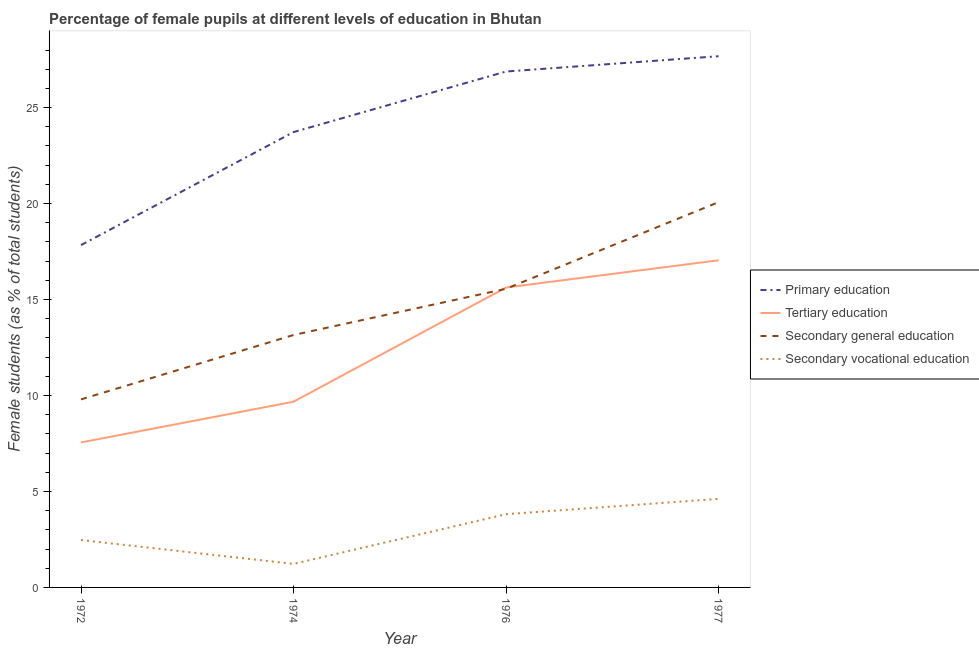How many different coloured lines are there?
Keep it short and to the point. 4. What is the percentage of female students in secondary vocational education in 1972?
Keep it short and to the point. 2.47. Across all years, what is the maximum percentage of female students in secondary vocational education?
Offer a very short reply. 4.61. Across all years, what is the minimum percentage of female students in tertiary education?
Provide a succinct answer. 7.55. In which year was the percentage of female students in secondary vocational education maximum?
Offer a terse response. 1977. In which year was the percentage of female students in secondary education minimum?
Offer a very short reply. 1972. What is the total percentage of female students in secondary vocational education in the graph?
Your answer should be very brief. 12.12. What is the difference between the percentage of female students in primary education in 1974 and that in 1977?
Make the answer very short. -3.95. What is the difference between the percentage of female students in secondary education in 1977 and the percentage of female students in tertiary education in 1976?
Provide a succinct answer. 4.45. What is the average percentage of female students in primary education per year?
Give a very brief answer. 24.03. In the year 1972, what is the difference between the percentage of female students in secondary vocational education and percentage of female students in secondary education?
Your answer should be very brief. -7.33. In how many years, is the percentage of female students in secondary vocational education greater than 4 %?
Your response must be concise. 1. What is the ratio of the percentage of female students in primary education in 1972 to that in 1974?
Offer a very short reply. 0.75. Is the percentage of female students in secondary vocational education in 1972 less than that in 1977?
Your answer should be compact. Yes. Is the difference between the percentage of female students in tertiary education in 1974 and 1977 greater than the difference between the percentage of female students in secondary education in 1974 and 1977?
Your answer should be compact. No. What is the difference between the highest and the second highest percentage of female students in primary education?
Offer a very short reply. 0.8. What is the difference between the highest and the lowest percentage of female students in secondary education?
Provide a short and direct response. 10.28. In how many years, is the percentage of female students in secondary vocational education greater than the average percentage of female students in secondary vocational education taken over all years?
Give a very brief answer. 2. Is it the case that in every year, the sum of the percentage of female students in secondary education and percentage of female students in tertiary education is greater than the sum of percentage of female students in secondary vocational education and percentage of female students in primary education?
Your answer should be compact. No. Is it the case that in every year, the sum of the percentage of female students in primary education and percentage of female students in tertiary education is greater than the percentage of female students in secondary education?
Your answer should be compact. Yes. Is the percentage of female students in secondary education strictly greater than the percentage of female students in tertiary education over the years?
Give a very brief answer. No. Is the percentage of female students in secondary education strictly less than the percentage of female students in secondary vocational education over the years?
Your answer should be very brief. No. How many lines are there?
Offer a terse response. 4. Does the graph contain grids?
Offer a very short reply. No. Where does the legend appear in the graph?
Provide a short and direct response. Center right. How many legend labels are there?
Offer a very short reply. 4. What is the title of the graph?
Keep it short and to the point. Percentage of female pupils at different levels of education in Bhutan. Does "Korea" appear as one of the legend labels in the graph?
Offer a very short reply. No. What is the label or title of the X-axis?
Ensure brevity in your answer.  Year. What is the label or title of the Y-axis?
Offer a very short reply. Female students (as % of total students). What is the Female students (as % of total students) in Primary education in 1972?
Provide a short and direct response. 17.84. What is the Female students (as % of total students) of Tertiary education in 1972?
Offer a very short reply. 7.55. What is the Female students (as % of total students) of Secondary general education in 1972?
Your answer should be compact. 9.8. What is the Female students (as % of total students) of Secondary vocational education in 1972?
Offer a terse response. 2.47. What is the Female students (as % of total students) in Primary education in 1974?
Provide a succinct answer. 23.72. What is the Female students (as % of total students) in Tertiary education in 1974?
Your answer should be compact. 9.68. What is the Female students (as % of total students) of Secondary general education in 1974?
Your answer should be very brief. 13.15. What is the Female students (as % of total students) of Secondary vocational education in 1974?
Your answer should be compact. 1.23. What is the Female students (as % of total students) in Primary education in 1976?
Give a very brief answer. 26.88. What is the Female students (as % of total students) of Tertiary education in 1976?
Provide a succinct answer. 15.62. What is the Female students (as % of total students) in Secondary general education in 1976?
Provide a succinct answer. 15.56. What is the Female students (as % of total students) in Secondary vocational education in 1976?
Offer a very short reply. 3.81. What is the Female students (as % of total students) in Primary education in 1977?
Ensure brevity in your answer.  27.68. What is the Female students (as % of total students) of Tertiary education in 1977?
Give a very brief answer. 17.04. What is the Female students (as % of total students) of Secondary general education in 1977?
Keep it short and to the point. 20.07. What is the Female students (as % of total students) of Secondary vocational education in 1977?
Your response must be concise. 4.61. Across all years, what is the maximum Female students (as % of total students) of Primary education?
Provide a succinct answer. 27.68. Across all years, what is the maximum Female students (as % of total students) in Tertiary education?
Provide a short and direct response. 17.04. Across all years, what is the maximum Female students (as % of total students) of Secondary general education?
Your answer should be very brief. 20.07. Across all years, what is the maximum Female students (as % of total students) in Secondary vocational education?
Your answer should be compact. 4.61. Across all years, what is the minimum Female students (as % of total students) of Primary education?
Your answer should be very brief. 17.84. Across all years, what is the minimum Female students (as % of total students) in Tertiary education?
Your response must be concise. 7.55. Across all years, what is the minimum Female students (as % of total students) in Secondary general education?
Ensure brevity in your answer.  9.8. Across all years, what is the minimum Female students (as % of total students) in Secondary vocational education?
Your answer should be compact. 1.23. What is the total Female students (as % of total students) in Primary education in the graph?
Your answer should be compact. 96.12. What is the total Female students (as % of total students) of Tertiary education in the graph?
Keep it short and to the point. 49.9. What is the total Female students (as % of total students) in Secondary general education in the graph?
Give a very brief answer. 58.58. What is the total Female students (as % of total students) in Secondary vocational education in the graph?
Your response must be concise. 12.12. What is the difference between the Female students (as % of total students) of Primary education in 1972 and that in 1974?
Provide a short and direct response. -5.89. What is the difference between the Female students (as % of total students) of Tertiary education in 1972 and that in 1974?
Ensure brevity in your answer.  -2.12. What is the difference between the Female students (as % of total students) in Secondary general education in 1972 and that in 1974?
Your response must be concise. -3.36. What is the difference between the Female students (as % of total students) of Secondary vocational education in 1972 and that in 1974?
Provide a short and direct response. 1.24. What is the difference between the Female students (as % of total students) of Primary education in 1972 and that in 1976?
Provide a short and direct response. -9.04. What is the difference between the Female students (as % of total students) in Tertiary education in 1972 and that in 1976?
Your response must be concise. -8.07. What is the difference between the Female students (as % of total students) in Secondary general education in 1972 and that in 1976?
Offer a terse response. -5.76. What is the difference between the Female students (as % of total students) of Secondary vocational education in 1972 and that in 1976?
Your answer should be very brief. -1.35. What is the difference between the Female students (as % of total students) of Primary education in 1972 and that in 1977?
Make the answer very short. -9.84. What is the difference between the Female students (as % of total students) of Tertiary education in 1972 and that in 1977?
Provide a succinct answer. -9.49. What is the difference between the Female students (as % of total students) of Secondary general education in 1972 and that in 1977?
Ensure brevity in your answer.  -10.28. What is the difference between the Female students (as % of total students) of Secondary vocational education in 1972 and that in 1977?
Provide a succinct answer. -2.14. What is the difference between the Female students (as % of total students) in Primary education in 1974 and that in 1976?
Keep it short and to the point. -3.16. What is the difference between the Female students (as % of total students) in Tertiary education in 1974 and that in 1976?
Keep it short and to the point. -5.95. What is the difference between the Female students (as % of total students) in Secondary general education in 1974 and that in 1976?
Make the answer very short. -2.41. What is the difference between the Female students (as % of total students) of Secondary vocational education in 1974 and that in 1976?
Ensure brevity in your answer.  -2.59. What is the difference between the Female students (as % of total students) in Primary education in 1974 and that in 1977?
Give a very brief answer. -3.95. What is the difference between the Female students (as % of total students) of Tertiary education in 1974 and that in 1977?
Provide a short and direct response. -7.37. What is the difference between the Female students (as % of total students) in Secondary general education in 1974 and that in 1977?
Give a very brief answer. -6.92. What is the difference between the Female students (as % of total students) of Secondary vocational education in 1974 and that in 1977?
Your response must be concise. -3.39. What is the difference between the Female students (as % of total students) in Primary education in 1976 and that in 1977?
Provide a short and direct response. -0.8. What is the difference between the Female students (as % of total students) in Tertiary education in 1976 and that in 1977?
Make the answer very short. -1.42. What is the difference between the Female students (as % of total students) in Secondary general education in 1976 and that in 1977?
Provide a short and direct response. -4.51. What is the difference between the Female students (as % of total students) in Secondary vocational education in 1976 and that in 1977?
Ensure brevity in your answer.  -0.8. What is the difference between the Female students (as % of total students) in Primary education in 1972 and the Female students (as % of total students) in Tertiary education in 1974?
Make the answer very short. 8.16. What is the difference between the Female students (as % of total students) in Primary education in 1972 and the Female students (as % of total students) in Secondary general education in 1974?
Ensure brevity in your answer.  4.68. What is the difference between the Female students (as % of total students) in Primary education in 1972 and the Female students (as % of total students) in Secondary vocational education in 1974?
Keep it short and to the point. 16.61. What is the difference between the Female students (as % of total students) of Tertiary education in 1972 and the Female students (as % of total students) of Secondary general education in 1974?
Offer a very short reply. -5.6. What is the difference between the Female students (as % of total students) of Tertiary education in 1972 and the Female students (as % of total students) of Secondary vocational education in 1974?
Offer a very short reply. 6.33. What is the difference between the Female students (as % of total students) of Secondary general education in 1972 and the Female students (as % of total students) of Secondary vocational education in 1974?
Provide a short and direct response. 8.57. What is the difference between the Female students (as % of total students) of Primary education in 1972 and the Female students (as % of total students) of Tertiary education in 1976?
Provide a short and direct response. 2.21. What is the difference between the Female students (as % of total students) in Primary education in 1972 and the Female students (as % of total students) in Secondary general education in 1976?
Your answer should be compact. 2.28. What is the difference between the Female students (as % of total students) of Primary education in 1972 and the Female students (as % of total students) of Secondary vocational education in 1976?
Provide a succinct answer. 14.02. What is the difference between the Female students (as % of total students) of Tertiary education in 1972 and the Female students (as % of total students) of Secondary general education in 1976?
Keep it short and to the point. -8.01. What is the difference between the Female students (as % of total students) of Tertiary education in 1972 and the Female students (as % of total students) of Secondary vocational education in 1976?
Provide a succinct answer. 3.74. What is the difference between the Female students (as % of total students) of Secondary general education in 1972 and the Female students (as % of total students) of Secondary vocational education in 1976?
Make the answer very short. 5.98. What is the difference between the Female students (as % of total students) of Primary education in 1972 and the Female students (as % of total students) of Tertiary education in 1977?
Make the answer very short. 0.79. What is the difference between the Female students (as % of total students) of Primary education in 1972 and the Female students (as % of total students) of Secondary general education in 1977?
Your answer should be compact. -2.24. What is the difference between the Female students (as % of total students) in Primary education in 1972 and the Female students (as % of total students) in Secondary vocational education in 1977?
Offer a very short reply. 13.22. What is the difference between the Female students (as % of total students) in Tertiary education in 1972 and the Female students (as % of total students) in Secondary general education in 1977?
Ensure brevity in your answer.  -12.52. What is the difference between the Female students (as % of total students) of Tertiary education in 1972 and the Female students (as % of total students) of Secondary vocational education in 1977?
Offer a terse response. 2.94. What is the difference between the Female students (as % of total students) in Secondary general education in 1972 and the Female students (as % of total students) in Secondary vocational education in 1977?
Provide a succinct answer. 5.18. What is the difference between the Female students (as % of total students) in Primary education in 1974 and the Female students (as % of total students) in Tertiary education in 1976?
Give a very brief answer. 8.1. What is the difference between the Female students (as % of total students) in Primary education in 1974 and the Female students (as % of total students) in Secondary general education in 1976?
Offer a very short reply. 8.16. What is the difference between the Female students (as % of total students) in Primary education in 1974 and the Female students (as % of total students) in Secondary vocational education in 1976?
Give a very brief answer. 19.91. What is the difference between the Female students (as % of total students) of Tertiary education in 1974 and the Female students (as % of total students) of Secondary general education in 1976?
Your answer should be very brief. -5.88. What is the difference between the Female students (as % of total students) of Tertiary education in 1974 and the Female students (as % of total students) of Secondary vocational education in 1976?
Offer a very short reply. 5.86. What is the difference between the Female students (as % of total students) in Secondary general education in 1974 and the Female students (as % of total students) in Secondary vocational education in 1976?
Ensure brevity in your answer.  9.34. What is the difference between the Female students (as % of total students) of Primary education in 1974 and the Female students (as % of total students) of Tertiary education in 1977?
Your answer should be very brief. 6.68. What is the difference between the Female students (as % of total students) in Primary education in 1974 and the Female students (as % of total students) in Secondary general education in 1977?
Give a very brief answer. 3.65. What is the difference between the Female students (as % of total students) in Primary education in 1974 and the Female students (as % of total students) in Secondary vocational education in 1977?
Keep it short and to the point. 19.11. What is the difference between the Female students (as % of total students) in Tertiary education in 1974 and the Female students (as % of total students) in Secondary general education in 1977?
Your answer should be compact. -10.4. What is the difference between the Female students (as % of total students) in Tertiary education in 1974 and the Female students (as % of total students) in Secondary vocational education in 1977?
Keep it short and to the point. 5.06. What is the difference between the Female students (as % of total students) in Secondary general education in 1974 and the Female students (as % of total students) in Secondary vocational education in 1977?
Give a very brief answer. 8.54. What is the difference between the Female students (as % of total students) of Primary education in 1976 and the Female students (as % of total students) of Tertiary education in 1977?
Give a very brief answer. 9.83. What is the difference between the Female students (as % of total students) in Primary education in 1976 and the Female students (as % of total students) in Secondary general education in 1977?
Provide a succinct answer. 6.81. What is the difference between the Female students (as % of total students) of Primary education in 1976 and the Female students (as % of total students) of Secondary vocational education in 1977?
Offer a terse response. 22.27. What is the difference between the Female students (as % of total students) of Tertiary education in 1976 and the Female students (as % of total students) of Secondary general education in 1977?
Make the answer very short. -4.45. What is the difference between the Female students (as % of total students) in Tertiary education in 1976 and the Female students (as % of total students) in Secondary vocational education in 1977?
Offer a terse response. 11.01. What is the difference between the Female students (as % of total students) in Secondary general education in 1976 and the Female students (as % of total students) in Secondary vocational education in 1977?
Make the answer very short. 10.95. What is the average Female students (as % of total students) of Primary education per year?
Your response must be concise. 24.03. What is the average Female students (as % of total students) in Tertiary education per year?
Provide a succinct answer. 12.47. What is the average Female students (as % of total students) of Secondary general education per year?
Give a very brief answer. 14.65. What is the average Female students (as % of total students) in Secondary vocational education per year?
Give a very brief answer. 3.03. In the year 1972, what is the difference between the Female students (as % of total students) of Primary education and Female students (as % of total students) of Tertiary education?
Offer a very short reply. 10.28. In the year 1972, what is the difference between the Female students (as % of total students) in Primary education and Female students (as % of total students) in Secondary general education?
Provide a succinct answer. 8.04. In the year 1972, what is the difference between the Female students (as % of total students) of Primary education and Female students (as % of total students) of Secondary vocational education?
Provide a short and direct response. 15.37. In the year 1972, what is the difference between the Female students (as % of total students) in Tertiary education and Female students (as % of total students) in Secondary general education?
Your answer should be very brief. -2.24. In the year 1972, what is the difference between the Female students (as % of total students) of Tertiary education and Female students (as % of total students) of Secondary vocational education?
Provide a succinct answer. 5.09. In the year 1972, what is the difference between the Female students (as % of total students) in Secondary general education and Female students (as % of total students) in Secondary vocational education?
Make the answer very short. 7.33. In the year 1974, what is the difference between the Female students (as % of total students) of Primary education and Female students (as % of total students) of Tertiary education?
Give a very brief answer. 14.05. In the year 1974, what is the difference between the Female students (as % of total students) in Primary education and Female students (as % of total students) in Secondary general education?
Offer a terse response. 10.57. In the year 1974, what is the difference between the Female students (as % of total students) in Primary education and Female students (as % of total students) in Secondary vocational education?
Keep it short and to the point. 22.5. In the year 1974, what is the difference between the Female students (as % of total students) in Tertiary education and Female students (as % of total students) in Secondary general education?
Offer a terse response. -3.48. In the year 1974, what is the difference between the Female students (as % of total students) of Tertiary education and Female students (as % of total students) of Secondary vocational education?
Your answer should be very brief. 8.45. In the year 1974, what is the difference between the Female students (as % of total students) of Secondary general education and Female students (as % of total students) of Secondary vocational education?
Your response must be concise. 11.93. In the year 1976, what is the difference between the Female students (as % of total students) of Primary education and Female students (as % of total students) of Tertiary education?
Keep it short and to the point. 11.25. In the year 1976, what is the difference between the Female students (as % of total students) of Primary education and Female students (as % of total students) of Secondary general education?
Offer a very short reply. 11.32. In the year 1976, what is the difference between the Female students (as % of total students) of Primary education and Female students (as % of total students) of Secondary vocational education?
Provide a succinct answer. 23.06. In the year 1976, what is the difference between the Female students (as % of total students) in Tertiary education and Female students (as % of total students) in Secondary general education?
Offer a very short reply. 0.07. In the year 1976, what is the difference between the Female students (as % of total students) in Tertiary education and Female students (as % of total students) in Secondary vocational education?
Your answer should be very brief. 11.81. In the year 1976, what is the difference between the Female students (as % of total students) of Secondary general education and Female students (as % of total students) of Secondary vocational education?
Make the answer very short. 11.75. In the year 1977, what is the difference between the Female students (as % of total students) of Primary education and Female students (as % of total students) of Tertiary education?
Give a very brief answer. 10.63. In the year 1977, what is the difference between the Female students (as % of total students) in Primary education and Female students (as % of total students) in Secondary general education?
Make the answer very short. 7.6. In the year 1977, what is the difference between the Female students (as % of total students) in Primary education and Female students (as % of total students) in Secondary vocational education?
Offer a terse response. 23.06. In the year 1977, what is the difference between the Female students (as % of total students) in Tertiary education and Female students (as % of total students) in Secondary general education?
Ensure brevity in your answer.  -3.03. In the year 1977, what is the difference between the Female students (as % of total students) in Tertiary education and Female students (as % of total students) in Secondary vocational education?
Offer a terse response. 12.43. In the year 1977, what is the difference between the Female students (as % of total students) in Secondary general education and Female students (as % of total students) in Secondary vocational education?
Your response must be concise. 15.46. What is the ratio of the Female students (as % of total students) in Primary education in 1972 to that in 1974?
Keep it short and to the point. 0.75. What is the ratio of the Female students (as % of total students) in Tertiary education in 1972 to that in 1974?
Provide a succinct answer. 0.78. What is the ratio of the Female students (as % of total students) in Secondary general education in 1972 to that in 1974?
Give a very brief answer. 0.74. What is the ratio of the Female students (as % of total students) of Secondary vocational education in 1972 to that in 1974?
Your answer should be very brief. 2.01. What is the ratio of the Female students (as % of total students) in Primary education in 1972 to that in 1976?
Keep it short and to the point. 0.66. What is the ratio of the Female students (as % of total students) of Tertiary education in 1972 to that in 1976?
Offer a very short reply. 0.48. What is the ratio of the Female students (as % of total students) of Secondary general education in 1972 to that in 1976?
Your answer should be very brief. 0.63. What is the ratio of the Female students (as % of total students) in Secondary vocational education in 1972 to that in 1976?
Offer a terse response. 0.65. What is the ratio of the Female students (as % of total students) of Primary education in 1972 to that in 1977?
Provide a succinct answer. 0.64. What is the ratio of the Female students (as % of total students) in Tertiary education in 1972 to that in 1977?
Your answer should be compact. 0.44. What is the ratio of the Female students (as % of total students) of Secondary general education in 1972 to that in 1977?
Make the answer very short. 0.49. What is the ratio of the Female students (as % of total students) of Secondary vocational education in 1972 to that in 1977?
Your response must be concise. 0.54. What is the ratio of the Female students (as % of total students) in Primary education in 1974 to that in 1976?
Give a very brief answer. 0.88. What is the ratio of the Female students (as % of total students) in Tertiary education in 1974 to that in 1976?
Your response must be concise. 0.62. What is the ratio of the Female students (as % of total students) in Secondary general education in 1974 to that in 1976?
Your response must be concise. 0.85. What is the ratio of the Female students (as % of total students) in Secondary vocational education in 1974 to that in 1976?
Offer a very short reply. 0.32. What is the ratio of the Female students (as % of total students) in Primary education in 1974 to that in 1977?
Offer a very short reply. 0.86. What is the ratio of the Female students (as % of total students) of Tertiary education in 1974 to that in 1977?
Your response must be concise. 0.57. What is the ratio of the Female students (as % of total students) in Secondary general education in 1974 to that in 1977?
Provide a short and direct response. 0.66. What is the ratio of the Female students (as % of total students) of Secondary vocational education in 1974 to that in 1977?
Provide a short and direct response. 0.27. What is the ratio of the Female students (as % of total students) of Primary education in 1976 to that in 1977?
Ensure brevity in your answer.  0.97. What is the ratio of the Female students (as % of total students) of Tertiary education in 1976 to that in 1977?
Offer a terse response. 0.92. What is the ratio of the Female students (as % of total students) of Secondary general education in 1976 to that in 1977?
Ensure brevity in your answer.  0.78. What is the ratio of the Female students (as % of total students) in Secondary vocational education in 1976 to that in 1977?
Provide a short and direct response. 0.83. What is the difference between the highest and the second highest Female students (as % of total students) of Primary education?
Provide a short and direct response. 0.8. What is the difference between the highest and the second highest Female students (as % of total students) of Tertiary education?
Your response must be concise. 1.42. What is the difference between the highest and the second highest Female students (as % of total students) of Secondary general education?
Keep it short and to the point. 4.51. What is the difference between the highest and the second highest Female students (as % of total students) in Secondary vocational education?
Ensure brevity in your answer.  0.8. What is the difference between the highest and the lowest Female students (as % of total students) in Primary education?
Your response must be concise. 9.84. What is the difference between the highest and the lowest Female students (as % of total students) in Tertiary education?
Your response must be concise. 9.49. What is the difference between the highest and the lowest Female students (as % of total students) of Secondary general education?
Provide a succinct answer. 10.28. What is the difference between the highest and the lowest Female students (as % of total students) of Secondary vocational education?
Your answer should be very brief. 3.39. 